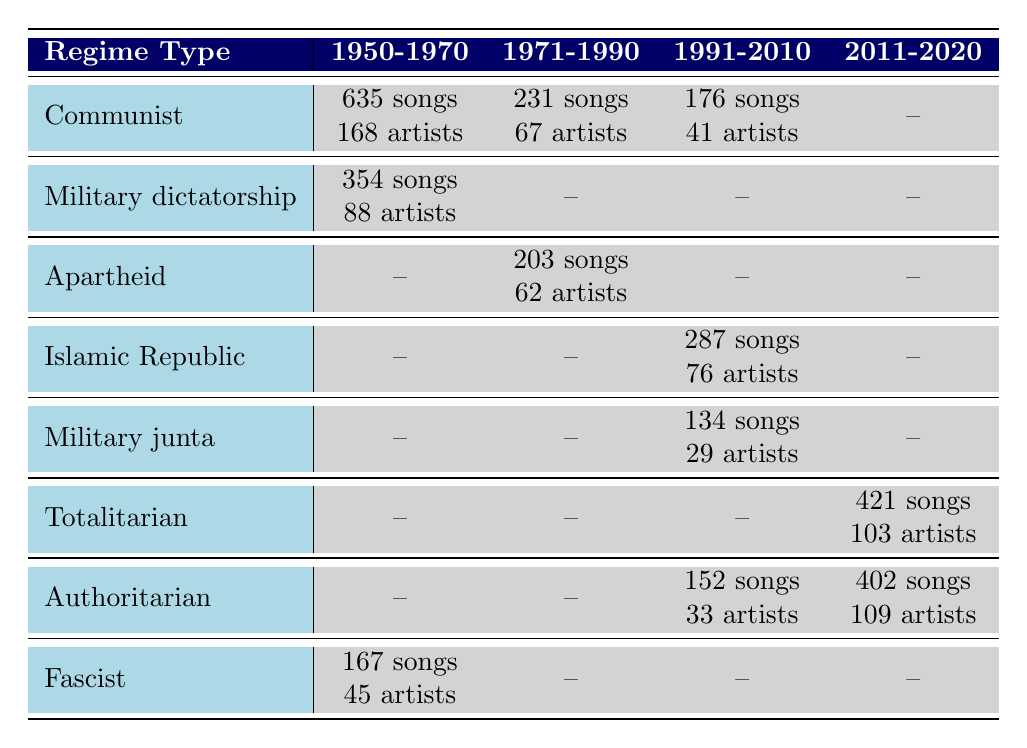What is the total number of censored songs in military dictatorships from 1950 to 1970? The total can be found by adding the censored songs in military dictatorship for the years listed. In 1970, there are 156 songs from Chile, and in 1975 Argentina, there are 198 songs. The sum is 156 + 198 = 354.
Answer: 354 Which regime type had the highest number of censored songs in the period from 2011 to 2020? From the table, total censored songs in that period are noted for Totalitarian (421 songs) and Authoritarian (402 songs). Totalitarian has the highest count.
Answer: Totalitarian How many different countries had music censorship under a Communist regime? By reviewing the table, the countries with a Communist regime are the Soviet Union, East Germany, China, Romania, and Cuba. Counting these gives us five unique countries.
Answer: 5 What is the average number of censored artists associated with military dictatorships from 1950 to 1970? For military dictatorships from 1950 to 1970, only data from Chile and Argentina is noted. There are 35 artists from Chile in 1970 and 53 artists from Argentina in 1975. The average is (35 + 53)/2 = 44.
Answer: 44 Did any Fascist regimes have more than 160 censored songs? Referring to the table, the only Fascist regime listed (Spain, 1965) had 167 censored songs, which is less than 160. Therefore, the statement is false.
Answer: No What is the difference in the number of censored songs between the highest and lowest number for any regime type in the 1990s? The regime type with the highest number of censored songs in the 1990s is the Islamic Republic of Iran with 287 songs, while the lowest is Cuba with 176 songs. The difference is 287 - 176 = 111.
Answer: 111 How many censored songs were recorded in authoritarian regimes from 1991 to 2020? The years indicate 152 songs (2005, Zimbabwe) and 402 songs (2015, Russia) for authoritarian regimes. Adding those gives 152 + 402 = 554.
Answer: 554 Which regime type had the most number of censored artists in the period from 2011 to 2020? The Totalitarian regime has 103 artists, and the Authoritarian regime shows 109 artists during that period. Authoritarian has more, thus it is the largest.
Answer: Authoritarian Is there a period where no censored songs were reported under military dictatorship? The table shows data with a military dictatorship between 1950 and 1970 (354 total) but no entries from 1971 to 2020, meaning there are periods without reported censored songs. Thus, it is true.
Answer: Yes 